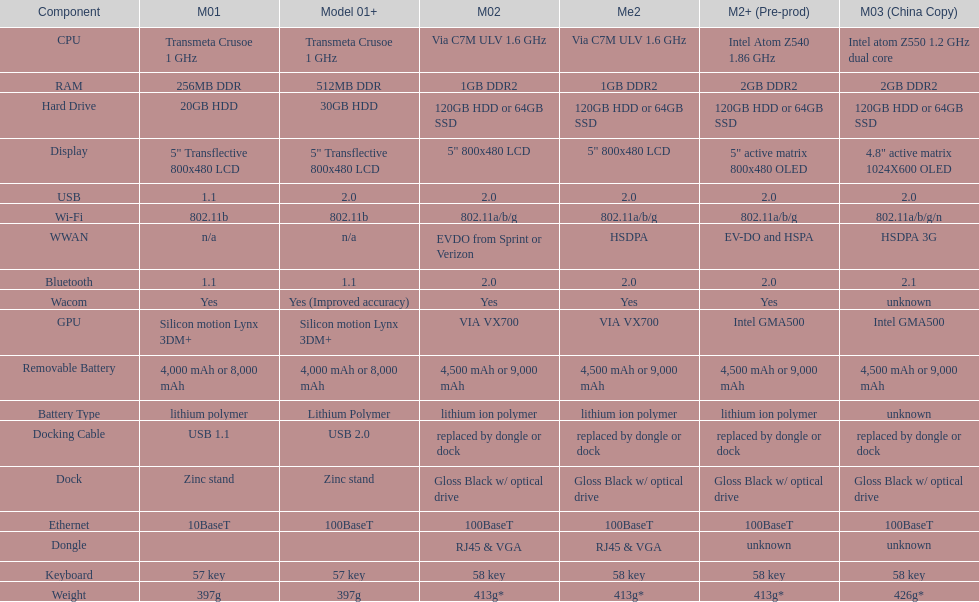What is the total number of components on the chart? 18. 